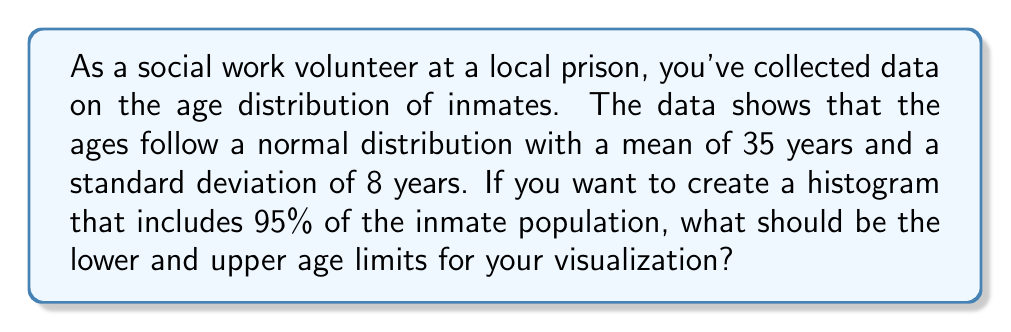What is the answer to this math problem? To solve this problem, we'll use the properties of the normal distribution and the concept of z-scores.

Step 1: Recall that in a normal distribution, approximately 95% of the data falls within 2 standard deviations of the mean.

Step 2: Calculate the z-score for 95% coverage:
Z-score for 95% = ±1.96 (from standard normal distribution tables)

Step 3: Use the z-score formula to calculate the age limits:
$$ X = \mu + Z\sigma $$
Where:
$X$ = age limit
$\mu$ = mean age (35 years)
$Z$ = z-score (±1.96)
$\sigma$ = standard deviation (8 years)

Step 4: Calculate the lower age limit:
$$ X_{lower} = 35 + (-1.96 \times 8) = 35 - 15.68 = 19.32 $$

Step 5: Calculate the upper age limit:
$$ X_{upper} = 35 + (1.96 \times 8) = 35 + 15.68 = 50.68 $$

Step 6: Round the results to the nearest whole number for practical use in the histogram:
Lower limit: 19 years
Upper limit: 51 years
Answer: 19 years and 51 years 